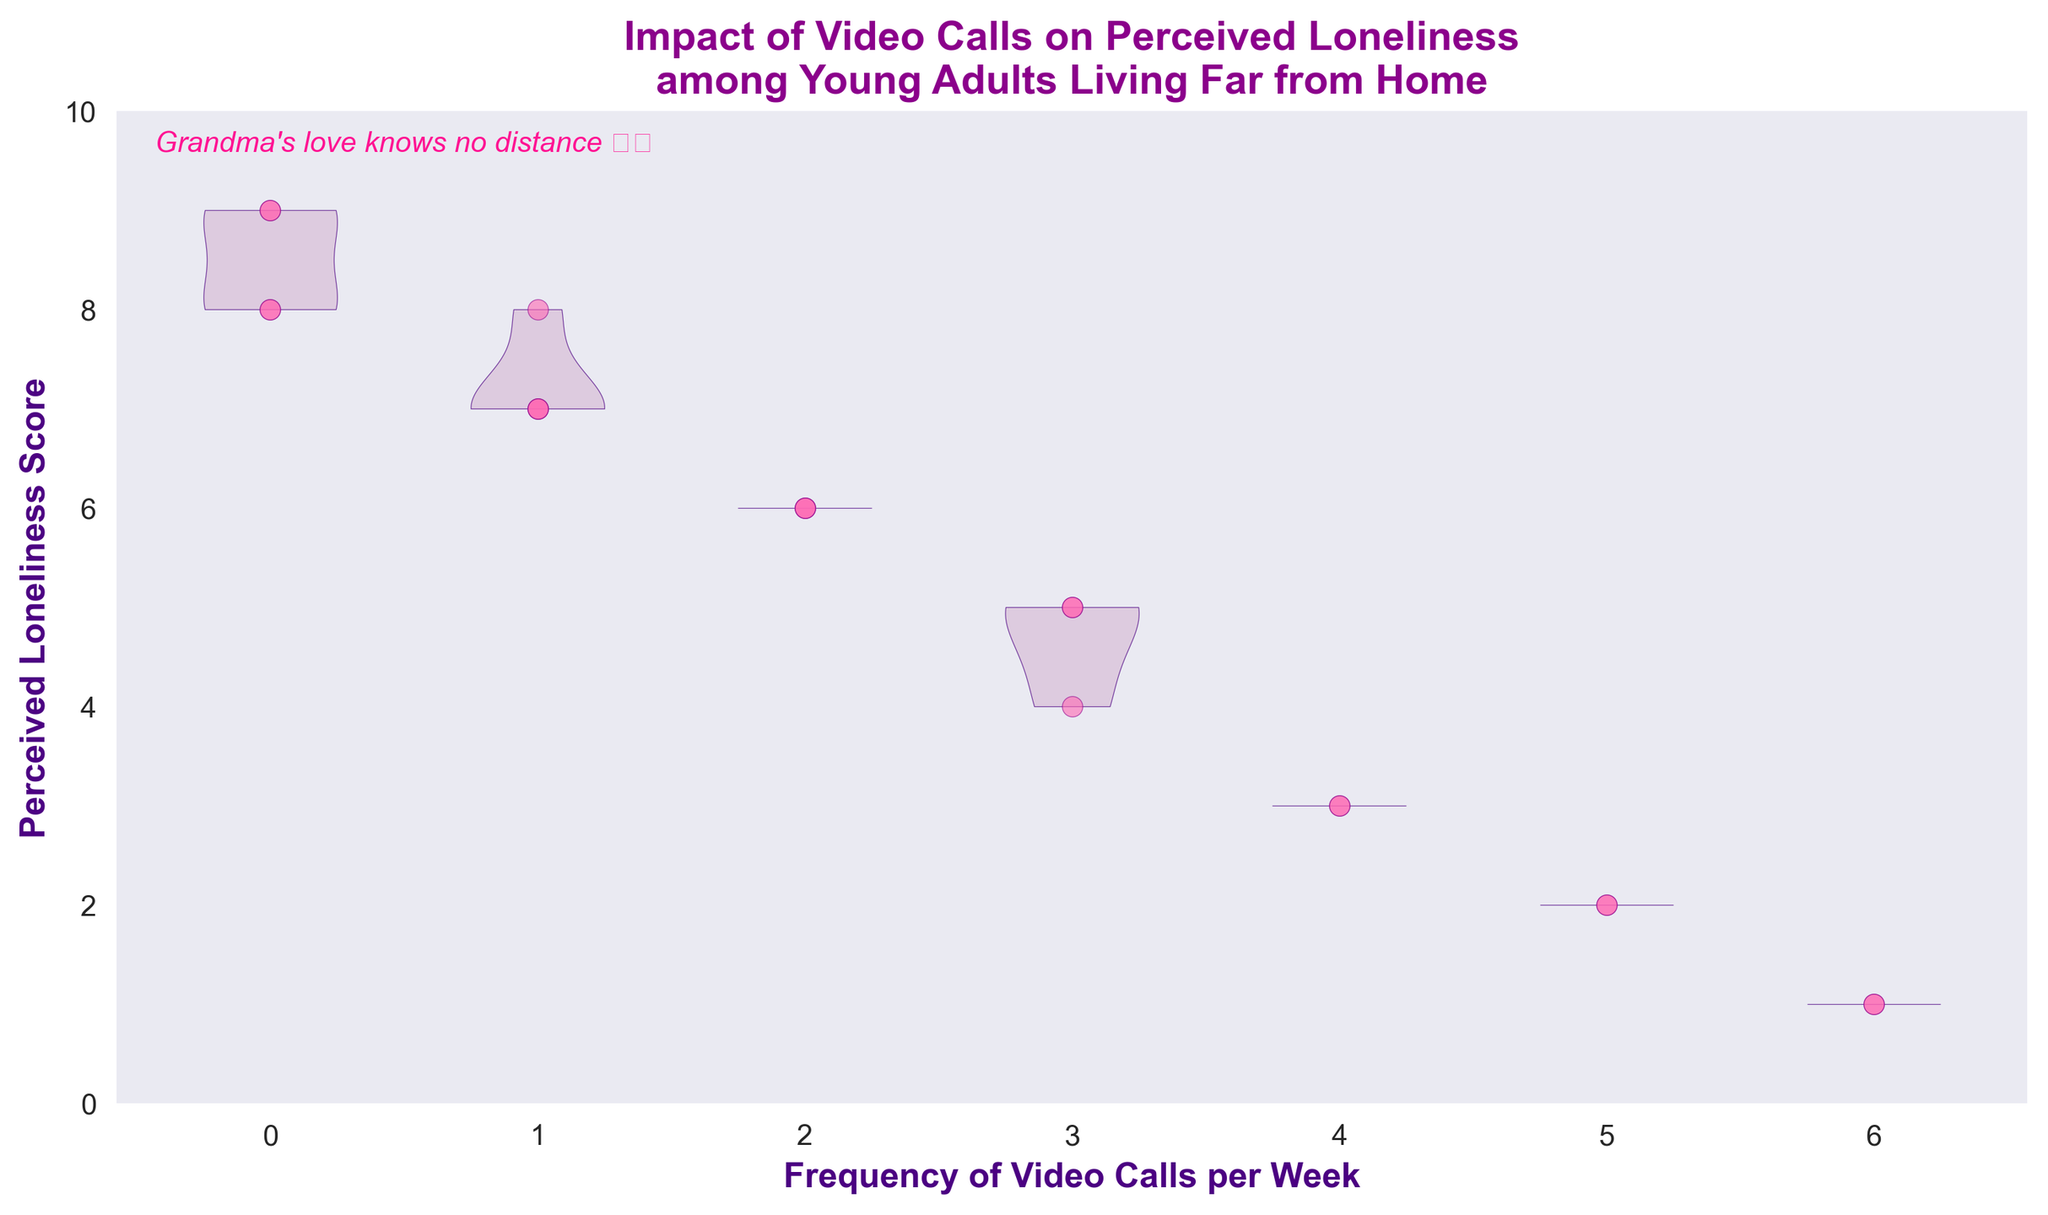What is the title of the figure? The title is located at the top of the figure, usually centered and in bold.
Answer: Impact of Video Calls on Perceived Loneliness among Young Adults Living Far from Home How many data points represent participants who make 3 video calls per week? Look at the scatter plot points at the '3' position on the x-axis.
Answer: 3 What is the maximum perceived loneliness score among participants who make zero video calls per week? Observe the highest vertical point in the violin plot for '0' on the x-axis.
Answer: 9 Compare the average loneliness scores for participants making 1 call and 2 calls per week. Which group has a higher average? Calculate the average scores by summing the values and dividing by the number of data points for each group. Participants with 1 call per week have scores: (7, 7, 7, 8) → Average = (7+7+7+8)/4 = 7.25. Participants with 2 calls per week have scores: (6, 6, 6) → Average = (6+6+6)/3 = 6.
Answer: Participants making 1 call per week How does the perceived loneliness change with an increase in the frequency of video calls? Observe the general trend of the scatter plot and violin plots.
Answer: It generally decreases Which frequency of video calls has the lowest perceived loneliness score observed on the chart? Look for the minimum score on the scatter plot points and violin plots.
Answer: 6 video calls per week What is the range of perceived loneliness scores for participants who make 3 video calls per week? Identify the lowest and highest scores for '3' on the x-axis from the violin plot.
Answer: 4 to 5 What does the color of the scatter plot points represent? Examine the scatter plot points. The color does not convey additional information here, it is used for visual distinction and aesthetics.
Answer: Aesthetic distinction Which frequency of video calls shows the widest distribution of perceived loneliness scores? Look at the width of the violin plots and how spread out the values are.
Answer: 0 video calls per week 